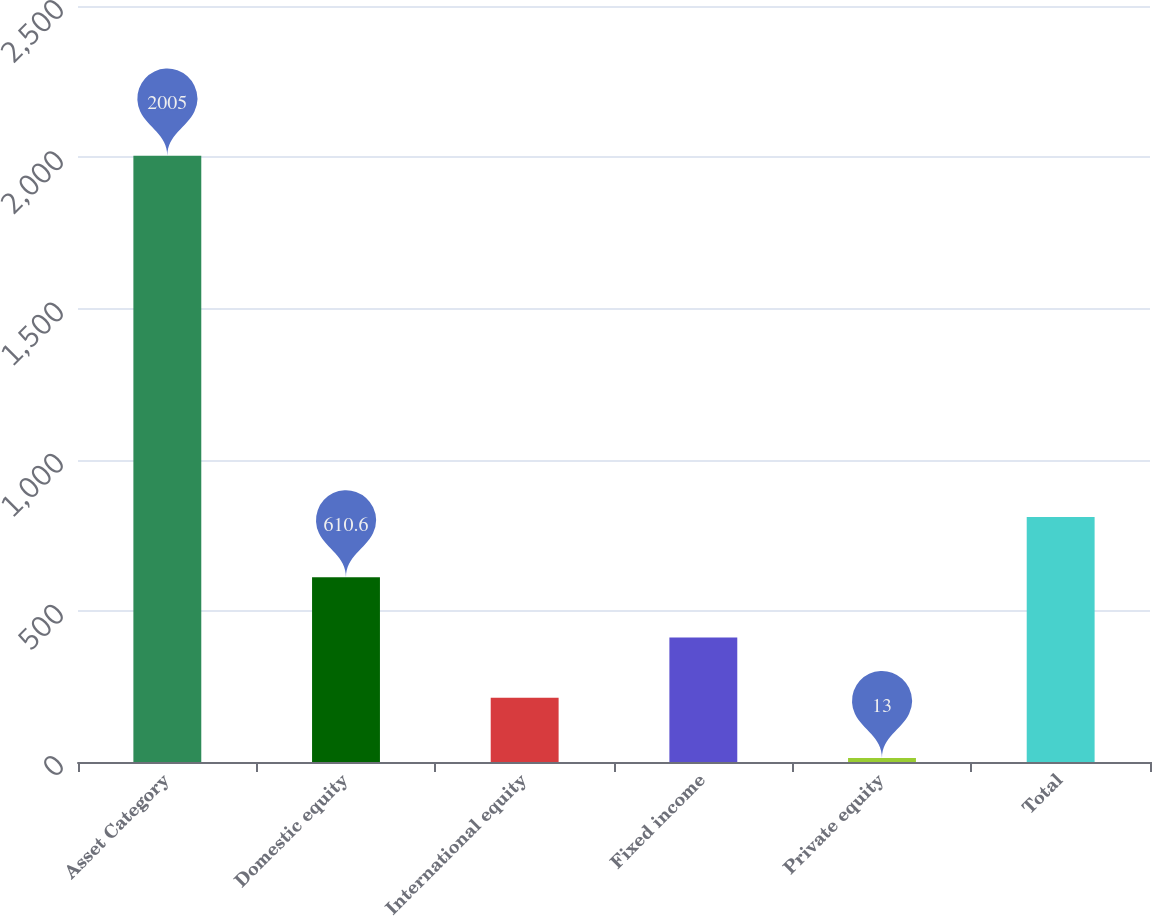Convert chart. <chart><loc_0><loc_0><loc_500><loc_500><bar_chart><fcel>Asset Category<fcel>Domestic equity<fcel>International equity<fcel>Fixed income<fcel>Private equity<fcel>Total<nl><fcel>2005<fcel>610.6<fcel>212.2<fcel>411.4<fcel>13<fcel>809.8<nl></chart> 